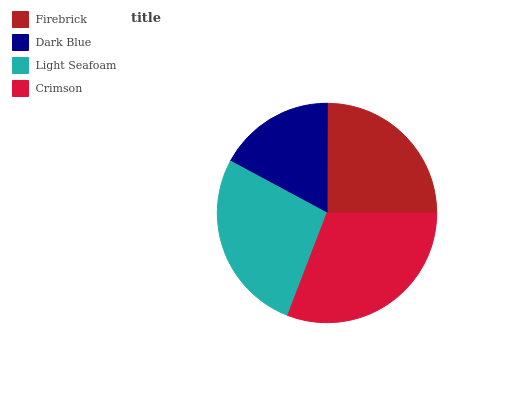Is Dark Blue the minimum?
Answer yes or no. Yes. Is Crimson the maximum?
Answer yes or no. Yes. Is Light Seafoam the minimum?
Answer yes or no. No. Is Light Seafoam the maximum?
Answer yes or no. No. Is Light Seafoam greater than Dark Blue?
Answer yes or no. Yes. Is Dark Blue less than Light Seafoam?
Answer yes or no. Yes. Is Dark Blue greater than Light Seafoam?
Answer yes or no. No. Is Light Seafoam less than Dark Blue?
Answer yes or no. No. Is Light Seafoam the high median?
Answer yes or no. Yes. Is Firebrick the low median?
Answer yes or no. Yes. Is Dark Blue the high median?
Answer yes or no. No. Is Dark Blue the low median?
Answer yes or no. No. 